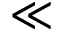<formula> <loc_0><loc_0><loc_500><loc_500>\ll</formula> 